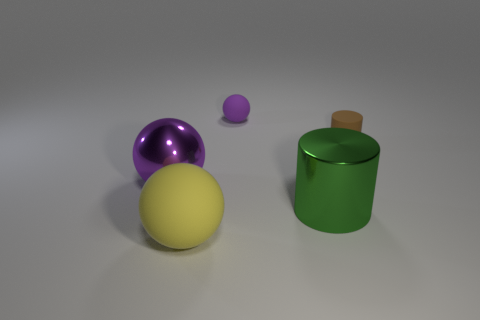What is the small purple sphere made of?
Your answer should be compact. Rubber. What is the color of the shiny cylinder?
Make the answer very short. Green. What is the color of the sphere that is in front of the tiny purple rubber thing and to the right of the large purple ball?
Offer a very short reply. Yellow. Is there anything else that has the same material as the yellow thing?
Your response must be concise. Yes. Is the small cylinder made of the same material as the thing that is on the left side of the large yellow sphere?
Your response must be concise. No. How big is the green cylinder in front of the purple sphere that is behind the tiny brown rubber cylinder?
Keep it short and to the point. Large. Is there any other thing that has the same color as the matte cylinder?
Provide a short and direct response. No. Are the cylinder in front of the large purple metallic object and the small ball behind the brown matte cylinder made of the same material?
Give a very brief answer. No. There is a object that is both behind the big green object and right of the tiny purple sphere; what material is it?
Give a very brief answer. Rubber. There is a tiny brown rubber thing; does it have the same shape as the purple object on the right side of the yellow matte ball?
Your response must be concise. No. 